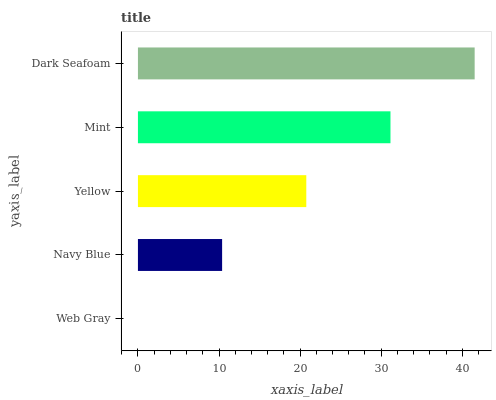Is Web Gray the minimum?
Answer yes or no. Yes. Is Dark Seafoam the maximum?
Answer yes or no. Yes. Is Navy Blue the minimum?
Answer yes or no. No. Is Navy Blue the maximum?
Answer yes or no. No. Is Navy Blue greater than Web Gray?
Answer yes or no. Yes. Is Web Gray less than Navy Blue?
Answer yes or no. Yes. Is Web Gray greater than Navy Blue?
Answer yes or no. No. Is Navy Blue less than Web Gray?
Answer yes or no. No. Is Yellow the high median?
Answer yes or no. Yes. Is Yellow the low median?
Answer yes or no. Yes. Is Web Gray the high median?
Answer yes or no. No. Is Dark Seafoam the low median?
Answer yes or no. No. 